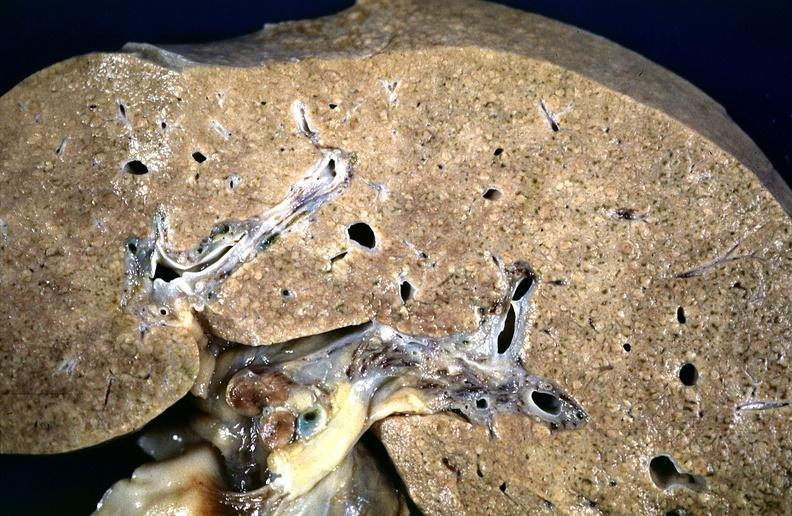what is present?
Answer the question using a single word or phrase. Hepatobiliary 